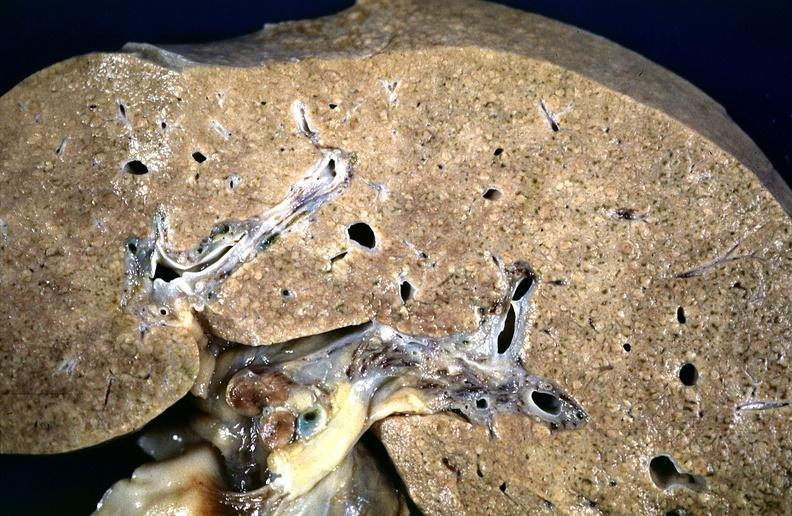what is present?
Answer the question using a single word or phrase. Hepatobiliary 